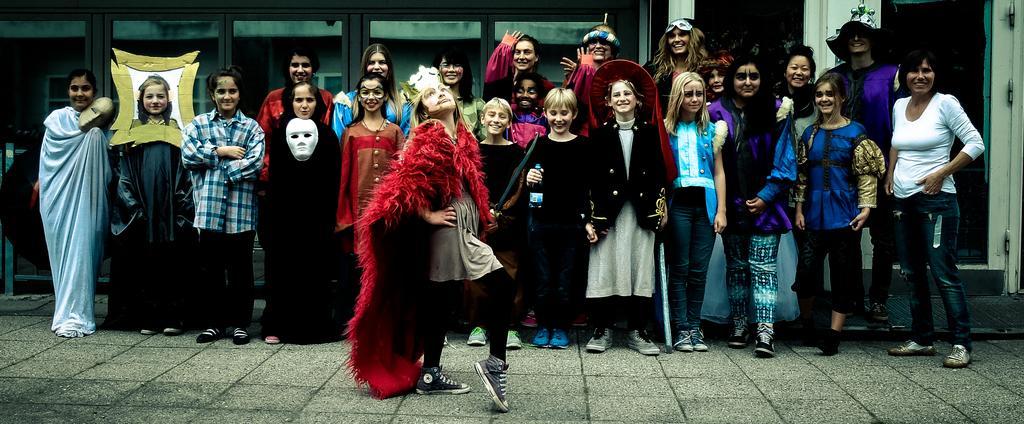How would you summarize this image in a sentence or two? In this image, we can see a group of people are standing on the platform and smiling. Few are holding some objects. Background we can see a glass door, wall. In the middle of the image, we can see a person is dancing on the floor. 